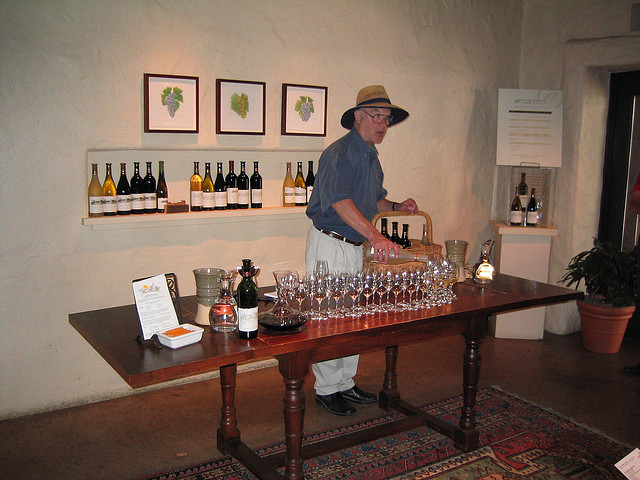<image>What game system is the man standing up playing? I don't know what game system the man is playing. It's ambiguous without an image. What game system is the man standing up playing? I don't know what game system the man standing up is playing. 